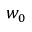<formula> <loc_0><loc_0><loc_500><loc_500>w _ { 0 }</formula> 